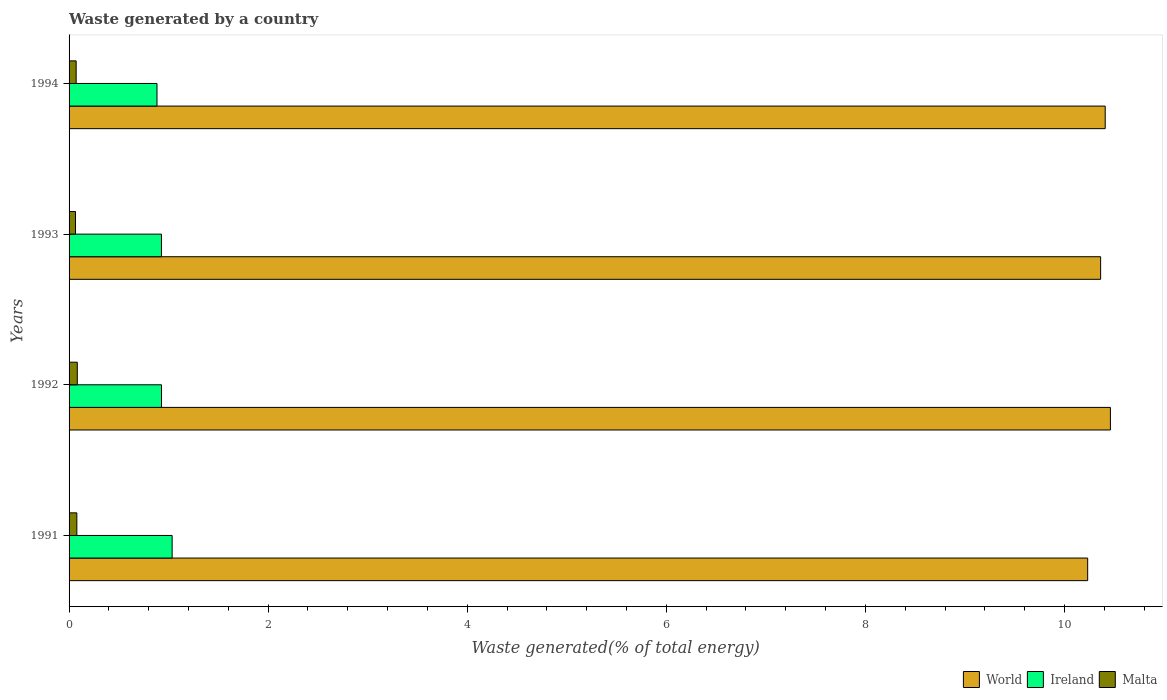Are the number of bars on each tick of the Y-axis equal?
Give a very brief answer. Yes. How many bars are there on the 4th tick from the bottom?
Offer a very short reply. 3. In how many cases, is the number of bars for a given year not equal to the number of legend labels?
Your answer should be very brief. 0. What is the total waste generated in Ireland in 1993?
Your response must be concise. 0.93. Across all years, what is the maximum total waste generated in World?
Make the answer very short. 10.46. Across all years, what is the minimum total waste generated in World?
Keep it short and to the point. 10.23. What is the total total waste generated in Ireland in the graph?
Your response must be concise. 3.77. What is the difference between the total waste generated in World in 1991 and that in 1994?
Your answer should be compact. -0.18. What is the difference between the total waste generated in World in 1994 and the total waste generated in Ireland in 1991?
Your response must be concise. 9.37. What is the average total waste generated in Ireland per year?
Your response must be concise. 0.94. In the year 1994, what is the difference between the total waste generated in World and total waste generated in Ireland?
Make the answer very short. 9.53. What is the ratio of the total waste generated in World in 1991 to that in 1992?
Offer a very short reply. 0.98. What is the difference between the highest and the second highest total waste generated in Malta?
Give a very brief answer. 0. What is the difference between the highest and the lowest total waste generated in Malta?
Offer a terse response. 0.02. Is the sum of the total waste generated in World in 1991 and 1993 greater than the maximum total waste generated in Ireland across all years?
Provide a short and direct response. Yes. What does the 1st bar from the top in 1991 represents?
Provide a succinct answer. Malta. What does the 3rd bar from the bottom in 1993 represents?
Provide a succinct answer. Malta. Is it the case that in every year, the sum of the total waste generated in Malta and total waste generated in World is greater than the total waste generated in Ireland?
Your answer should be compact. Yes. Are all the bars in the graph horizontal?
Offer a terse response. Yes. How many years are there in the graph?
Your response must be concise. 4. What is the difference between two consecutive major ticks on the X-axis?
Offer a very short reply. 2. Does the graph contain grids?
Provide a succinct answer. No. Where does the legend appear in the graph?
Your answer should be compact. Bottom right. How many legend labels are there?
Your response must be concise. 3. What is the title of the graph?
Provide a succinct answer. Waste generated by a country. What is the label or title of the X-axis?
Offer a terse response. Waste generated(% of total energy). What is the label or title of the Y-axis?
Ensure brevity in your answer.  Years. What is the Waste generated(% of total energy) of World in 1991?
Your answer should be very brief. 10.23. What is the Waste generated(% of total energy) in Ireland in 1991?
Your answer should be compact. 1.04. What is the Waste generated(% of total energy) in Malta in 1991?
Offer a very short reply. 0.08. What is the Waste generated(% of total energy) of World in 1992?
Give a very brief answer. 10.46. What is the Waste generated(% of total energy) of Ireland in 1992?
Keep it short and to the point. 0.93. What is the Waste generated(% of total energy) in Malta in 1992?
Provide a short and direct response. 0.08. What is the Waste generated(% of total energy) in World in 1993?
Offer a terse response. 10.36. What is the Waste generated(% of total energy) of Ireland in 1993?
Keep it short and to the point. 0.93. What is the Waste generated(% of total energy) in Malta in 1993?
Offer a very short reply. 0.06. What is the Waste generated(% of total energy) in World in 1994?
Give a very brief answer. 10.41. What is the Waste generated(% of total energy) in Ireland in 1994?
Your response must be concise. 0.88. What is the Waste generated(% of total energy) of Malta in 1994?
Offer a terse response. 0.07. Across all years, what is the maximum Waste generated(% of total energy) in World?
Provide a succinct answer. 10.46. Across all years, what is the maximum Waste generated(% of total energy) of Ireland?
Your response must be concise. 1.04. Across all years, what is the maximum Waste generated(% of total energy) in Malta?
Provide a short and direct response. 0.08. Across all years, what is the minimum Waste generated(% of total energy) in World?
Offer a very short reply. 10.23. Across all years, what is the minimum Waste generated(% of total energy) of Ireland?
Your answer should be very brief. 0.88. Across all years, what is the minimum Waste generated(% of total energy) of Malta?
Provide a short and direct response. 0.06. What is the total Waste generated(% of total energy) of World in the graph?
Your response must be concise. 41.47. What is the total Waste generated(% of total energy) in Ireland in the graph?
Offer a terse response. 3.77. What is the total Waste generated(% of total energy) in Malta in the graph?
Give a very brief answer. 0.3. What is the difference between the Waste generated(% of total energy) of World in 1991 and that in 1992?
Offer a terse response. -0.23. What is the difference between the Waste generated(% of total energy) in Ireland in 1991 and that in 1992?
Give a very brief answer. 0.11. What is the difference between the Waste generated(% of total energy) of Malta in 1991 and that in 1992?
Give a very brief answer. -0. What is the difference between the Waste generated(% of total energy) in World in 1991 and that in 1993?
Provide a short and direct response. -0.13. What is the difference between the Waste generated(% of total energy) of Ireland in 1991 and that in 1993?
Provide a short and direct response. 0.11. What is the difference between the Waste generated(% of total energy) in Malta in 1991 and that in 1993?
Ensure brevity in your answer.  0.01. What is the difference between the Waste generated(% of total energy) in World in 1991 and that in 1994?
Offer a terse response. -0.18. What is the difference between the Waste generated(% of total energy) in Ireland in 1991 and that in 1994?
Offer a terse response. 0.15. What is the difference between the Waste generated(% of total energy) in Malta in 1991 and that in 1994?
Your answer should be very brief. 0.01. What is the difference between the Waste generated(% of total energy) of World in 1992 and that in 1993?
Ensure brevity in your answer.  0.1. What is the difference between the Waste generated(% of total energy) in Malta in 1992 and that in 1993?
Offer a very short reply. 0.02. What is the difference between the Waste generated(% of total energy) in World in 1992 and that in 1994?
Your answer should be compact. 0.05. What is the difference between the Waste generated(% of total energy) of Ireland in 1992 and that in 1994?
Your response must be concise. 0.05. What is the difference between the Waste generated(% of total energy) in Malta in 1992 and that in 1994?
Provide a short and direct response. 0.01. What is the difference between the Waste generated(% of total energy) of World in 1993 and that in 1994?
Your answer should be compact. -0.05. What is the difference between the Waste generated(% of total energy) of Ireland in 1993 and that in 1994?
Provide a succinct answer. 0.04. What is the difference between the Waste generated(% of total energy) of Malta in 1993 and that in 1994?
Offer a very short reply. -0.01. What is the difference between the Waste generated(% of total energy) of World in 1991 and the Waste generated(% of total energy) of Ireland in 1992?
Offer a terse response. 9.3. What is the difference between the Waste generated(% of total energy) in World in 1991 and the Waste generated(% of total energy) in Malta in 1992?
Your response must be concise. 10.15. What is the difference between the Waste generated(% of total energy) in Ireland in 1991 and the Waste generated(% of total energy) in Malta in 1992?
Your answer should be compact. 0.95. What is the difference between the Waste generated(% of total energy) in World in 1991 and the Waste generated(% of total energy) in Ireland in 1993?
Make the answer very short. 9.31. What is the difference between the Waste generated(% of total energy) of World in 1991 and the Waste generated(% of total energy) of Malta in 1993?
Give a very brief answer. 10.17. What is the difference between the Waste generated(% of total energy) in Ireland in 1991 and the Waste generated(% of total energy) in Malta in 1993?
Your answer should be compact. 0.97. What is the difference between the Waste generated(% of total energy) of World in 1991 and the Waste generated(% of total energy) of Ireland in 1994?
Your answer should be very brief. 9.35. What is the difference between the Waste generated(% of total energy) in World in 1991 and the Waste generated(% of total energy) in Malta in 1994?
Your response must be concise. 10.16. What is the difference between the Waste generated(% of total energy) of Ireland in 1991 and the Waste generated(% of total energy) of Malta in 1994?
Offer a terse response. 0.96. What is the difference between the Waste generated(% of total energy) in World in 1992 and the Waste generated(% of total energy) in Ireland in 1993?
Your response must be concise. 9.53. What is the difference between the Waste generated(% of total energy) in World in 1992 and the Waste generated(% of total energy) in Malta in 1993?
Your answer should be compact. 10.4. What is the difference between the Waste generated(% of total energy) in Ireland in 1992 and the Waste generated(% of total energy) in Malta in 1993?
Offer a terse response. 0.86. What is the difference between the Waste generated(% of total energy) of World in 1992 and the Waste generated(% of total energy) of Ireland in 1994?
Make the answer very short. 9.58. What is the difference between the Waste generated(% of total energy) in World in 1992 and the Waste generated(% of total energy) in Malta in 1994?
Your answer should be very brief. 10.39. What is the difference between the Waste generated(% of total energy) in Ireland in 1992 and the Waste generated(% of total energy) in Malta in 1994?
Give a very brief answer. 0.86. What is the difference between the Waste generated(% of total energy) of World in 1993 and the Waste generated(% of total energy) of Ireland in 1994?
Your answer should be compact. 9.48. What is the difference between the Waste generated(% of total energy) of World in 1993 and the Waste generated(% of total energy) of Malta in 1994?
Give a very brief answer. 10.29. What is the difference between the Waste generated(% of total energy) of Ireland in 1993 and the Waste generated(% of total energy) of Malta in 1994?
Ensure brevity in your answer.  0.86. What is the average Waste generated(% of total energy) of World per year?
Make the answer very short. 10.37. What is the average Waste generated(% of total energy) in Ireland per year?
Offer a terse response. 0.94. What is the average Waste generated(% of total energy) in Malta per year?
Ensure brevity in your answer.  0.07. In the year 1991, what is the difference between the Waste generated(% of total energy) of World and Waste generated(% of total energy) of Ireland?
Offer a very short reply. 9.2. In the year 1991, what is the difference between the Waste generated(% of total energy) in World and Waste generated(% of total energy) in Malta?
Provide a succinct answer. 10.15. In the year 1991, what is the difference between the Waste generated(% of total energy) of Ireland and Waste generated(% of total energy) of Malta?
Your answer should be compact. 0.96. In the year 1992, what is the difference between the Waste generated(% of total energy) in World and Waste generated(% of total energy) in Ireland?
Ensure brevity in your answer.  9.53. In the year 1992, what is the difference between the Waste generated(% of total energy) in World and Waste generated(% of total energy) in Malta?
Offer a terse response. 10.38. In the year 1992, what is the difference between the Waste generated(% of total energy) in Ireland and Waste generated(% of total energy) in Malta?
Provide a short and direct response. 0.85. In the year 1993, what is the difference between the Waste generated(% of total energy) in World and Waste generated(% of total energy) in Ireland?
Make the answer very short. 9.44. In the year 1993, what is the difference between the Waste generated(% of total energy) in World and Waste generated(% of total energy) in Malta?
Give a very brief answer. 10.3. In the year 1993, what is the difference between the Waste generated(% of total energy) of Ireland and Waste generated(% of total energy) of Malta?
Your answer should be very brief. 0.86. In the year 1994, what is the difference between the Waste generated(% of total energy) in World and Waste generated(% of total energy) in Ireland?
Offer a terse response. 9.53. In the year 1994, what is the difference between the Waste generated(% of total energy) of World and Waste generated(% of total energy) of Malta?
Ensure brevity in your answer.  10.34. In the year 1994, what is the difference between the Waste generated(% of total energy) in Ireland and Waste generated(% of total energy) in Malta?
Your answer should be very brief. 0.81. What is the ratio of the Waste generated(% of total energy) in World in 1991 to that in 1992?
Offer a terse response. 0.98. What is the ratio of the Waste generated(% of total energy) of Ireland in 1991 to that in 1992?
Your answer should be compact. 1.12. What is the ratio of the Waste generated(% of total energy) in Malta in 1991 to that in 1992?
Provide a succinct answer. 0.95. What is the ratio of the Waste generated(% of total energy) in World in 1991 to that in 1993?
Ensure brevity in your answer.  0.99. What is the ratio of the Waste generated(% of total energy) in Ireland in 1991 to that in 1993?
Keep it short and to the point. 1.12. What is the ratio of the Waste generated(% of total energy) in Malta in 1991 to that in 1993?
Keep it short and to the point. 1.21. What is the ratio of the Waste generated(% of total energy) of World in 1991 to that in 1994?
Keep it short and to the point. 0.98. What is the ratio of the Waste generated(% of total energy) of Ireland in 1991 to that in 1994?
Offer a very short reply. 1.17. What is the ratio of the Waste generated(% of total energy) in Malta in 1991 to that in 1994?
Provide a succinct answer. 1.1. What is the ratio of the Waste generated(% of total energy) in World in 1992 to that in 1993?
Provide a short and direct response. 1.01. What is the ratio of the Waste generated(% of total energy) of Malta in 1992 to that in 1993?
Ensure brevity in your answer.  1.28. What is the ratio of the Waste generated(% of total energy) in Ireland in 1992 to that in 1994?
Offer a terse response. 1.05. What is the ratio of the Waste generated(% of total energy) of Malta in 1992 to that in 1994?
Offer a terse response. 1.16. What is the ratio of the Waste generated(% of total energy) of World in 1993 to that in 1994?
Your response must be concise. 1. What is the ratio of the Waste generated(% of total energy) of Ireland in 1993 to that in 1994?
Offer a very short reply. 1.05. What is the ratio of the Waste generated(% of total energy) of Malta in 1993 to that in 1994?
Your response must be concise. 0.91. What is the difference between the highest and the second highest Waste generated(% of total energy) of World?
Give a very brief answer. 0.05. What is the difference between the highest and the second highest Waste generated(% of total energy) in Ireland?
Offer a terse response. 0.11. What is the difference between the highest and the second highest Waste generated(% of total energy) in Malta?
Your response must be concise. 0. What is the difference between the highest and the lowest Waste generated(% of total energy) of World?
Offer a terse response. 0.23. What is the difference between the highest and the lowest Waste generated(% of total energy) of Ireland?
Your response must be concise. 0.15. What is the difference between the highest and the lowest Waste generated(% of total energy) in Malta?
Ensure brevity in your answer.  0.02. 